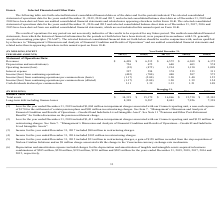According to Nielsen Nv's financial document, What does the loss for the year ended December 31, 2019 include? $1,004 million in impairment charges associated with our Connect reporting unit, a non-cash expense of $170 for the settlement of certain pension plans and $80 million in restructuring charges. The document states: "Loss for the year ended December 31, 2019 included $1,004 million in impairment charges associated with our Connect reporting unit, a non-cash expense..." Also, What does the income for the year ended December 31, 2017 include? $80 million in restructuring charges. The document states: "70 for the settlement of certain pension plans and $80 million in restructuring charges. See Item 7. “Management’s Discussion and Analysis of Financia..." Also, What is the amount of total assets in 2019? According to the financial document, 14,319 (in millions). The relevant text states: "Total assets $ 14,319 $ 15,179 $ 16,866 $ 15,730 $ 15,303..." Also, How many of the years have revenue above 6,500 million? Counting the relevant items in the document: 2018 ,  2017, I find 2 instances. The key data points involved are: 2017, 2018. Additionally, Which year has the highest amount of total assets? According to the financial document, 2017. The relevant text states: "a for the years ended December 31, 2019, 2018 and 2017, and selected consolidated balance sheet data as of December 31, 2019 and 2018 have been derived fr..." Also, can you calculate: What is the percentage change in the operating loss from 2018 to 2019? To answer this question, I need to perform calculations using the financial data. The calculation is: (93-475)/475, which equals -80.42 (percentage). This is based on the information: "Operating income/(loss) (93) (475) 1,214 1,130 1,098 Operating income/(loss) (93) (475) 1,214 1,130 1,098..." The key data points involved are: 475, 93. 